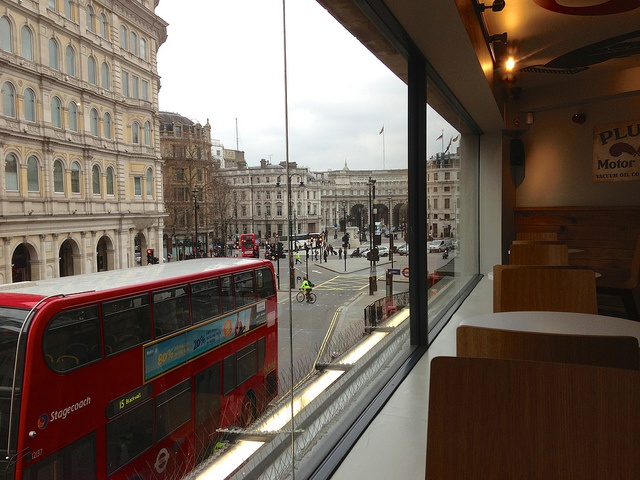Describe the objects in this image and their specific colors. I can see bus in gray, black, maroon, and lightgray tones, chair in gray and black tones, chair in gray, black, maroon, and darkgray tones, chair in gray and maroon tones, and dining table in gray and black tones in this image. 